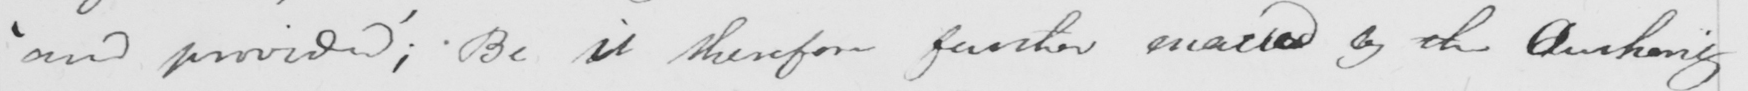What does this handwritten line say? ' and provided '  ; Be it therefore further enacted by the Authority 